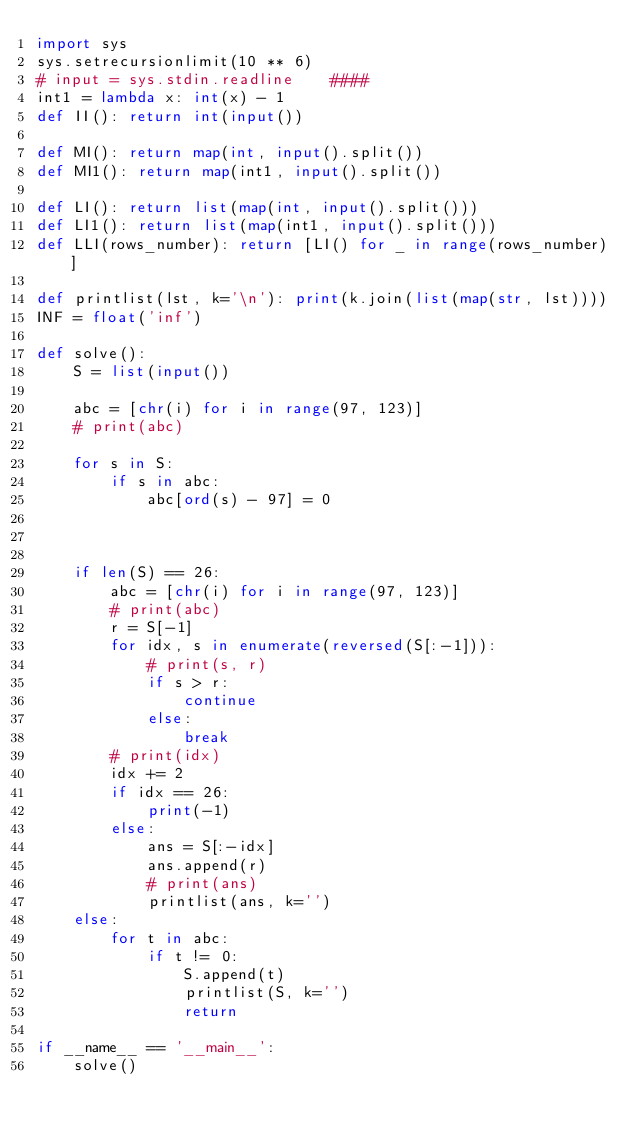<code> <loc_0><loc_0><loc_500><loc_500><_Python_>import sys
sys.setrecursionlimit(10 ** 6)
# input = sys.stdin.readline    ####
int1 = lambda x: int(x) - 1
def II(): return int(input())

def MI(): return map(int, input().split())
def MI1(): return map(int1, input().split())

def LI(): return list(map(int, input().split()))
def LI1(): return list(map(int1, input().split()))
def LLI(rows_number): return [LI() for _ in range(rows_number)]

def printlist(lst, k='\n'): print(k.join(list(map(str, lst))))
INF = float('inf')

def solve():
    S = list(input())

    abc = [chr(i) for i in range(97, 123)]
    # print(abc)

    for s in S:
        if s in abc:
            abc[ord(s) - 97] = 0



    if len(S) == 26:
        abc = [chr(i) for i in range(97, 123)]
        # print(abc)
        r = S[-1]
        for idx, s in enumerate(reversed(S[:-1])):
            # print(s, r)
            if s > r:
                continue
            else:
                break
        # print(idx)
        idx += 2
        if idx == 26:
            print(-1)
        else:
            ans = S[:-idx]
            ans.append(r)
            # print(ans)
            printlist(ans, k='')
    else:
        for t in abc:
            if t != 0:
                S.append(t)
                printlist(S, k='')
                return

if __name__ == '__main__':
    solve()
</code> 